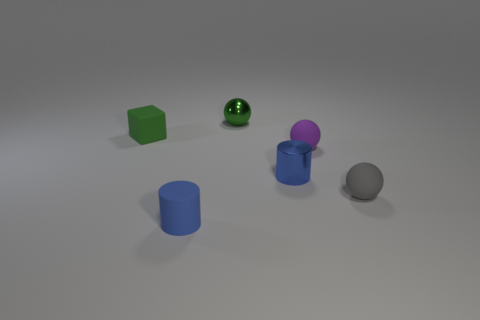Are there any other things that have the same shape as the green matte thing?
Give a very brief answer. No. How many spheres are small purple rubber objects or small rubber objects?
Provide a succinct answer. 2. There is a tiny thing that is left of the small metal sphere and in front of the green matte thing; what is its shape?
Offer a terse response. Cylinder. The tiny cylinder on the left side of the small shiny thing left of the cylinder that is behind the small blue matte cylinder is what color?
Keep it short and to the point. Blue. Are there fewer tiny green balls behind the small green ball than rubber things?
Your answer should be compact. Yes. Do the thing right of the small purple matte sphere and the green object that is right of the small rubber block have the same shape?
Give a very brief answer. Yes. What number of objects are small objects in front of the blue metallic cylinder or small shiny cylinders?
Your response must be concise. 3. There is a ball that is the same color as the small block; what is its material?
Provide a short and direct response. Metal. There is a gray sphere on the right side of the tiny thing that is behind the green matte thing; is there a blue shiny thing that is in front of it?
Provide a succinct answer. No. Are there fewer small spheres to the right of the purple rubber object than tiny rubber objects that are on the left side of the blue shiny object?
Offer a very short reply. Yes. 